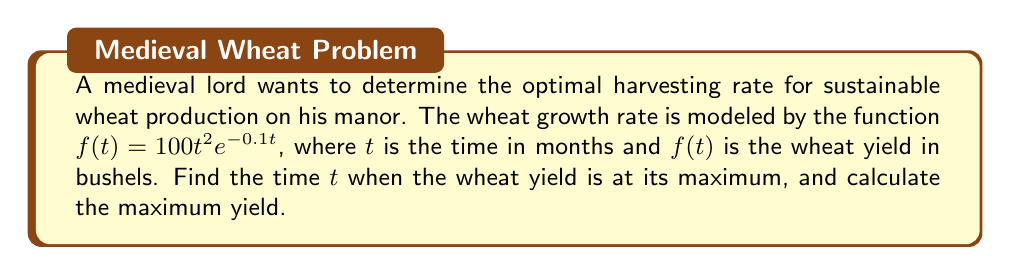Help me with this question. To find the maximum yield, we need to find the critical point of the function $f(t)$ and evaluate it.

Step 1: Calculate the derivative of $f(t)$
Using the product rule and chain rule:
$$f'(t) = (100t^2)(-0.1e^{-0.1t}) + (e^{-0.1t})(200t)$$
$$f'(t) = -10t^2e^{-0.1t} + 200te^{-0.1t}$$
$$f'(t) = e^{-0.1t}(-10t^2 + 200t)$$
$$f'(t) = 10te^{-0.1t}(-t + 20)$$

Step 2: Set $f'(t) = 0$ and solve for $t$
$$10te^{-0.1t}(-t + 20) = 0$$
$e^{-0.1t}$ is never 0, so either $t = 0$ or $-t + 20 = 0$
$t = 0$ is not a valid solution as it represents the beginning of growth.
Solving $-t + 20 = 0$, we get $t = 20$

Step 3: Verify this is a maximum by checking the second derivative
$$f''(t) = 10e^{-0.1t}(-t + 20) + 10te^{-0.1t}(-1)$$
At $t = 20$:
$$f''(20) = 10e^{-2}(-20 + 20) + 10(20)e^{-2}(-1) = -200e^{-2} < 0$$
Since $f''(20) < 0$, this confirms that $t = 20$ is a maximum.

Step 4: Calculate the maximum yield
$$f(20) = 100(20)^2e^{-0.1(20)} = 40000e^{-2} \approx 5413.41$$

Therefore, the optimal time to harvest is at 20 months, with a maximum yield of approximately 5413.41 bushels.
Answer: Optimal harvest time: 20 months; Maximum yield: $40000e^{-2} \approx 5413.41$ bushels 